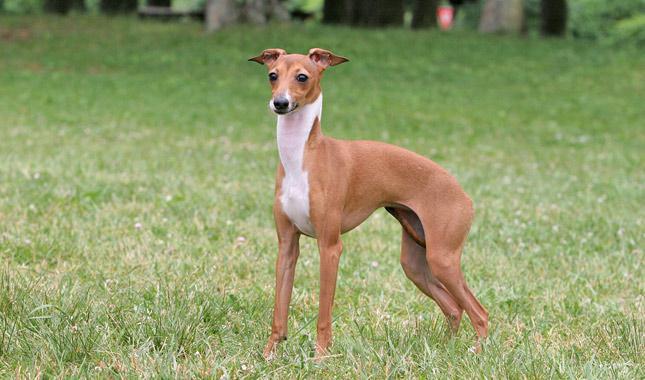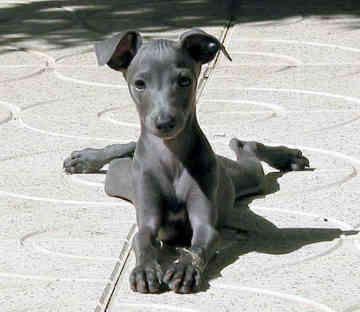The first image is the image on the left, the second image is the image on the right. For the images shown, is this caption "Exactly one of the dogs is standing, and it is posed on green grass with body in profile." true? Answer yes or no. Yes. The first image is the image on the left, the second image is the image on the right. Given the left and right images, does the statement "There is a dog with a solid gray face in one of the images." hold true? Answer yes or no. Yes. 